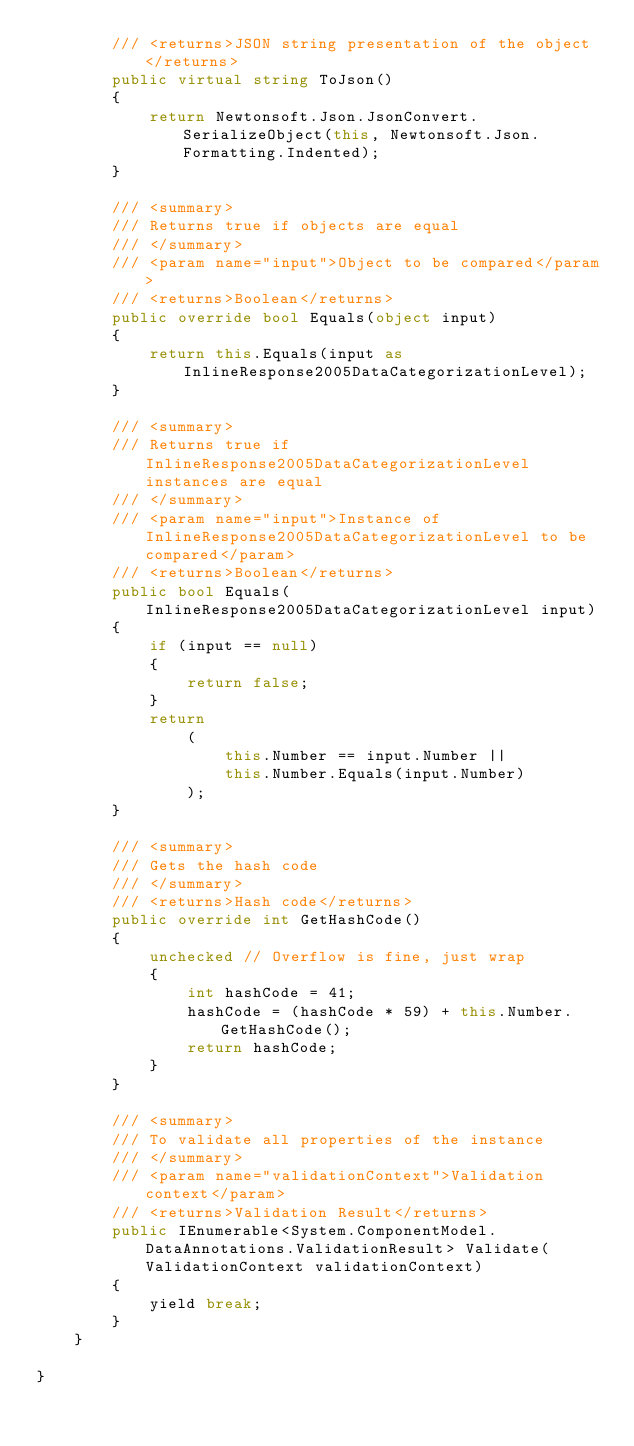<code> <loc_0><loc_0><loc_500><loc_500><_C#_>        /// <returns>JSON string presentation of the object</returns>
        public virtual string ToJson()
        {
            return Newtonsoft.Json.JsonConvert.SerializeObject(this, Newtonsoft.Json.Formatting.Indented);
        }

        /// <summary>
        /// Returns true if objects are equal
        /// </summary>
        /// <param name="input">Object to be compared</param>
        /// <returns>Boolean</returns>
        public override bool Equals(object input)
        {
            return this.Equals(input as InlineResponse2005DataCategorizationLevel);
        }

        /// <summary>
        /// Returns true if InlineResponse2005DataCategorizationLevel instances are equal
        /// </summary>
        /// <param name="input">Instance of InlineResponse2005DataCategorizationLevel to be compared</param>
        /// <returns>Boolean</returns>
        public bool Equals(InlineResponse2005DataCategorizationLevel input)
        {
            if (input == null)
            {
                return false;
            }
            return 
                (
                    this.Number == input.Number ||
                    this.Number.Equals(input.Number)
                );
        }

        /// <summary>
        /// Gets the hash code
        /// </summary>
        /// <returns>Hash code</returns>
        public override int GetHashCode()
        {
            unchecked // Overflow is fine, just wrap
            {
                int hashCode = 41;
                hashCode = (hashCode * 59) + this.Number.GetHashCode();
                return hashCode;
            }
        }

        /// <summary>
        /// To validate all properties of the instance
        /// </summary>
        /// <param name="validationContext">Validation context</param>
        /// <returns>Validation Result</returns>
        public IEnumerable<System.ComponentModel.DataAnnotations.ValidationResult> Validate(ValidationContext validationContext)
        {
            yield break;
        }
    }

}
</code> 